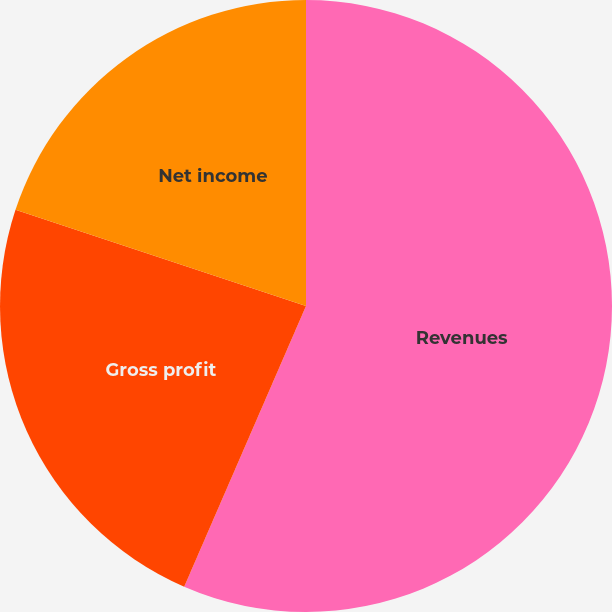Convert chart. <chart><loc_0><loc_0><loc_500><loc_500><pie_chart><fcel>Revenues<fcel>Gross profit<fcel>Net income<nl><fcel>56.51%<fcel>23.57%<fcel>19.91%<nl></chart> 